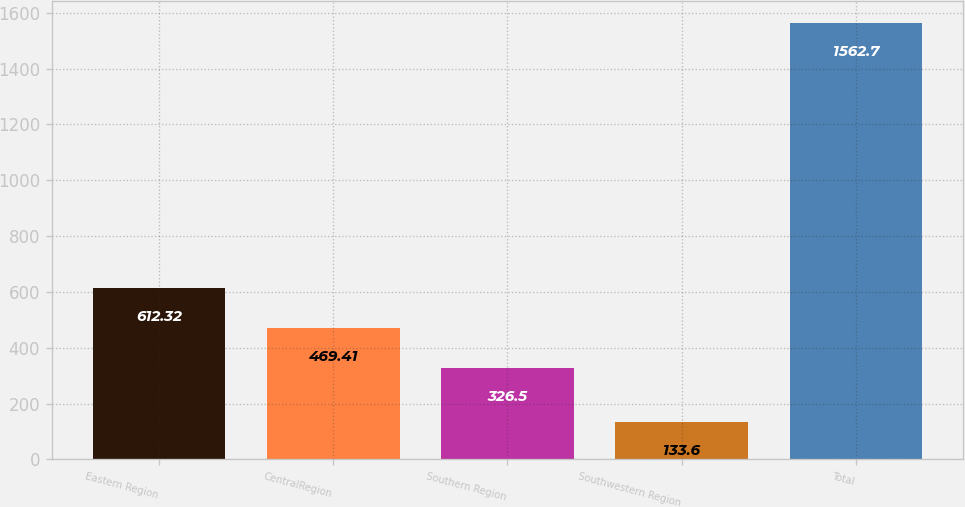Convert chart. <chart><loc_0><loc_0><loc_500><loc_500><bar_chart><fcel>Eastern Region<fcel>CentralRegion<fcel>Southern Region<fcel>Southwestern Region<fcel>Total<nl><fcel>612.32<fcel>469.41<fcel>326.5<fcel>133.6<fcel>1562.7<nl></chart> 